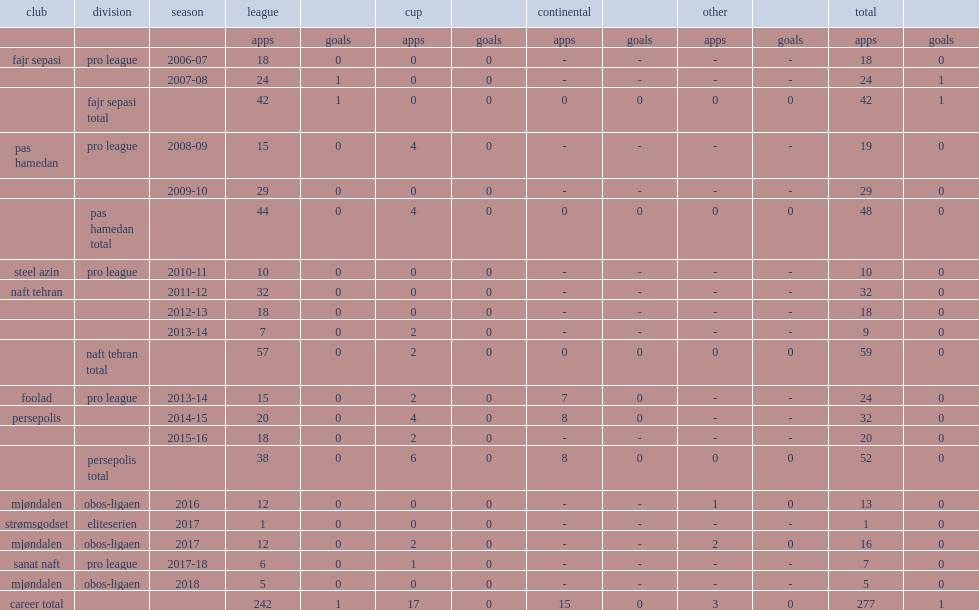Which league did makani play for foolad in the pro league season? 2013-14. 